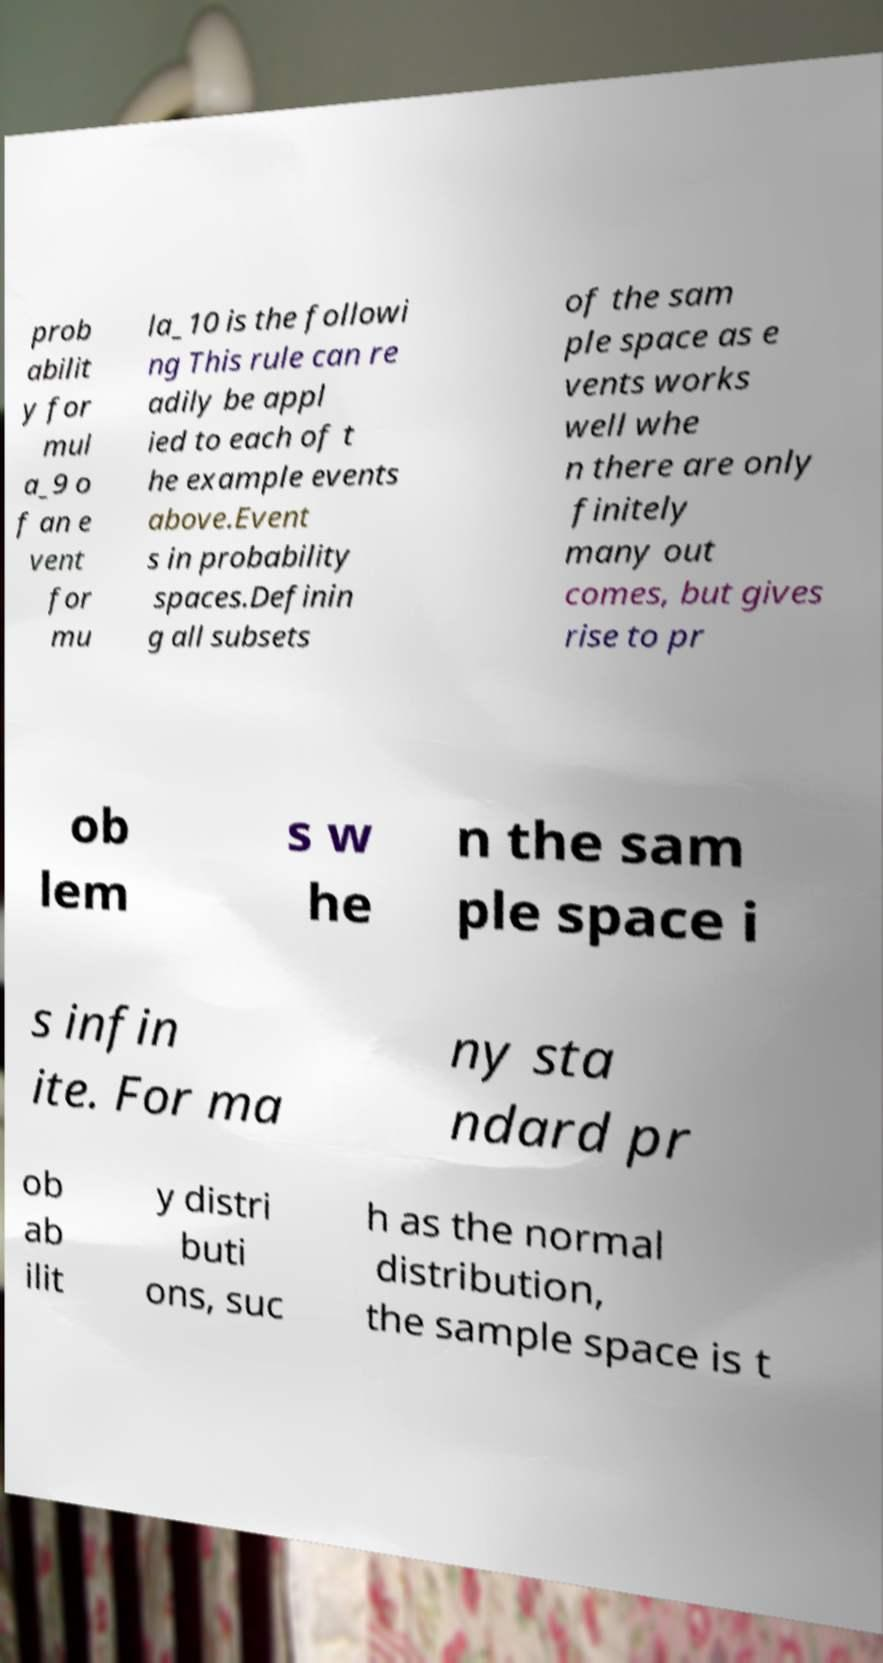Please read and relay the text visible in this image. What does it say? prob abilit y for mul a_9 o f an e vent for mu la_10 is the followi ng This rule can re adily be appl ied to each of t he example events above.Event s in probability spaces.Definin g all subsets of the sam ple space as e vents works well whe n there are only finitely many out comes, but gives rise to pr ob lem s w he n the sam ple space i s infin ite. For ma ny sta ndard pr ob ab ilit y distri buti ons, suc h as the normal distribution, the sample space is t 